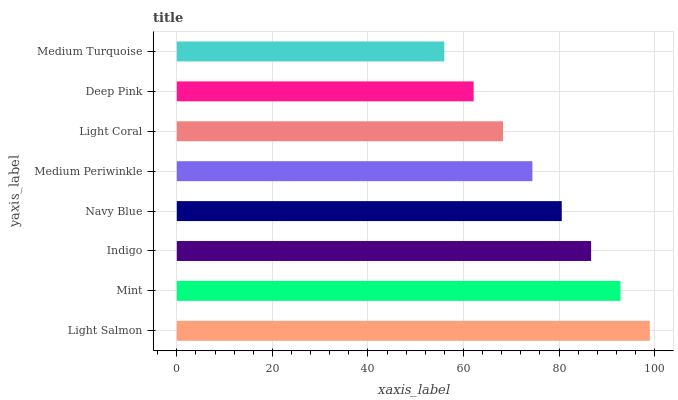Is Medium Turquoise the minimum?
Answer yes or no. Yes. Is Light Salmon the maximum?
Answer yes or no. Yes. Is Mint the minimum?
Answer yes or no. No. Is Mint the maximum?
Answer yes or no. No. Is Light Salmon greater than Mint?
Answer yes or no. Yes. Is Mint less than Light Salmon?
Answer yes or no. Yes. Is Mint greater than Light Salmon?
Answer yes or no. No. Is Light Salmon less than Mint?
Answer yes or no. No. Is Navy Blue the high median?
Answer yes or no. Yes. Is Medium Periwinkle the low median?
Answer yes or no. Yes. Is Medium Periwinkle the high median?
Answer yes or no. No. Is Navy Blue the low median?
Answer yes or no. No. 